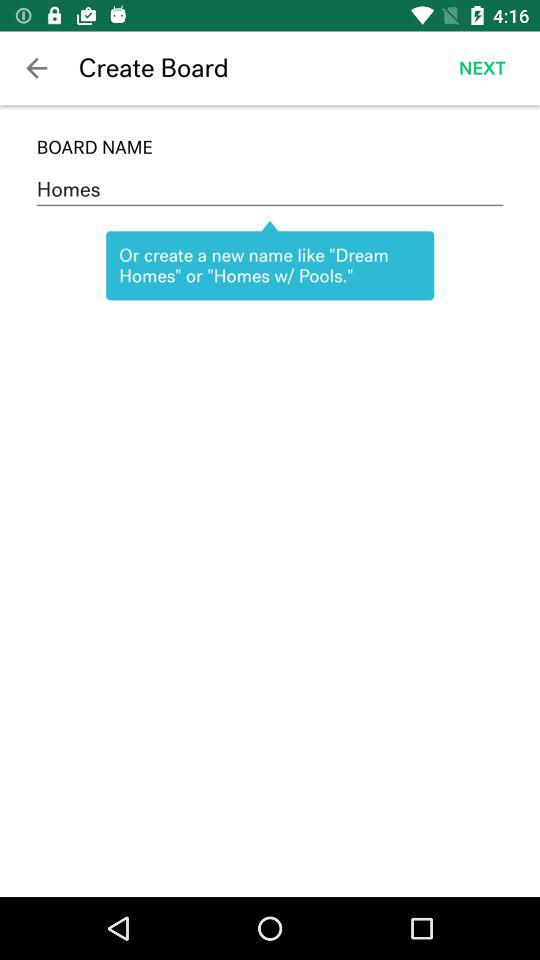What is the mentioned board name? The mentioned board name is Homes. 